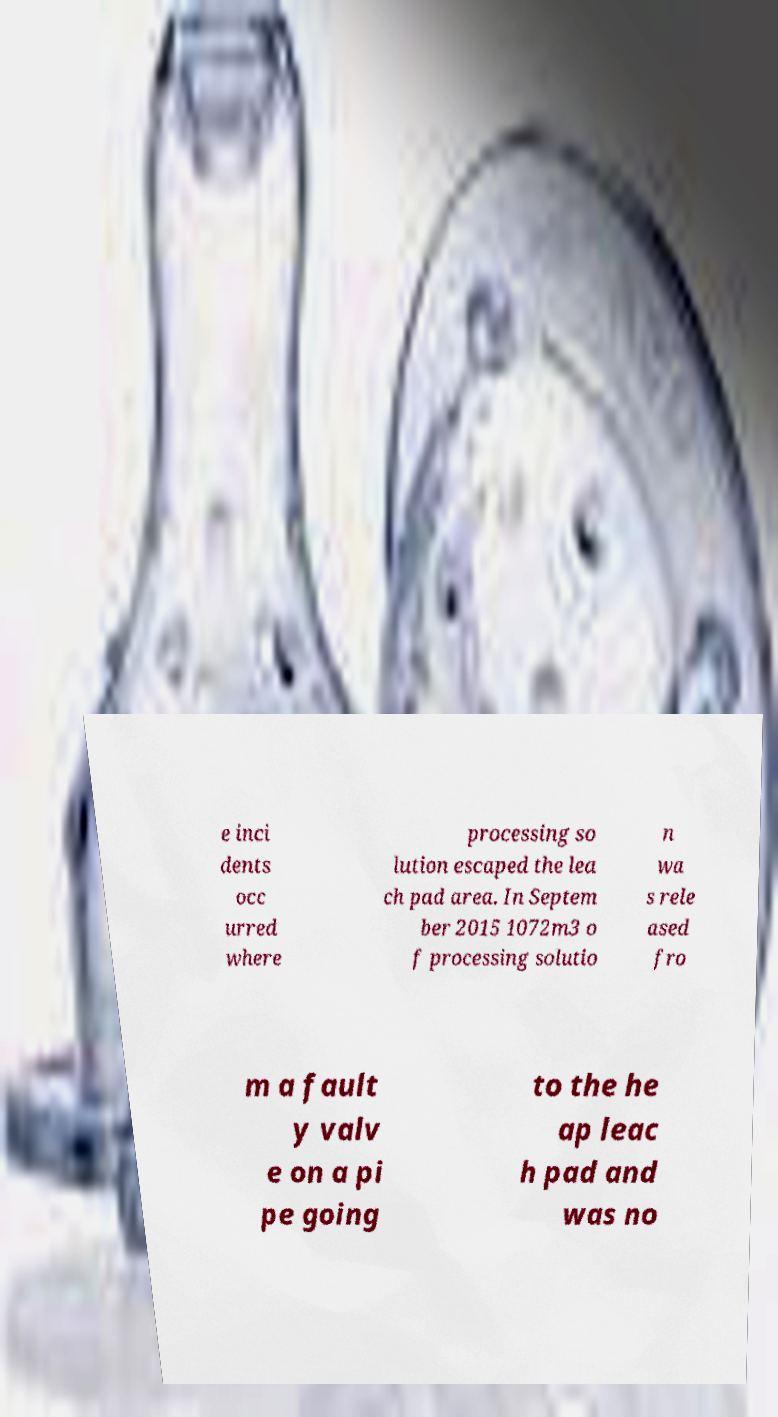For documentation purposes, I need the text within this image transcribed. Could you provide that? e inci dents occ urred where processing so lution escaped the lea ch pad area. In Septem ber 2015 1072m3 o f processing solutio n wa s rele ased fro m a fault y valv e on a pi pe going to the he ap leac h pad and was no 